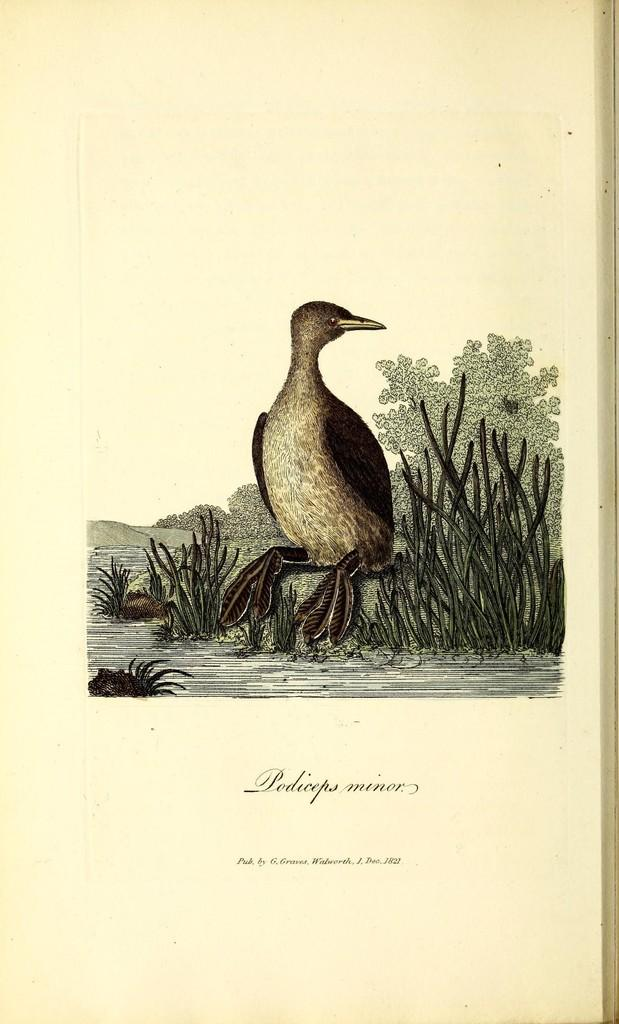What is depicted in the painting that is visible in the image? There is a painting of a bird in the image. What type of natural environment is visible in the image? There is grass, trees, and water visible in the image. Is there any text or writing present in the image? Yes, there is writing on the image. What type of gate can be seen in the image? There is no gate present in the image. 